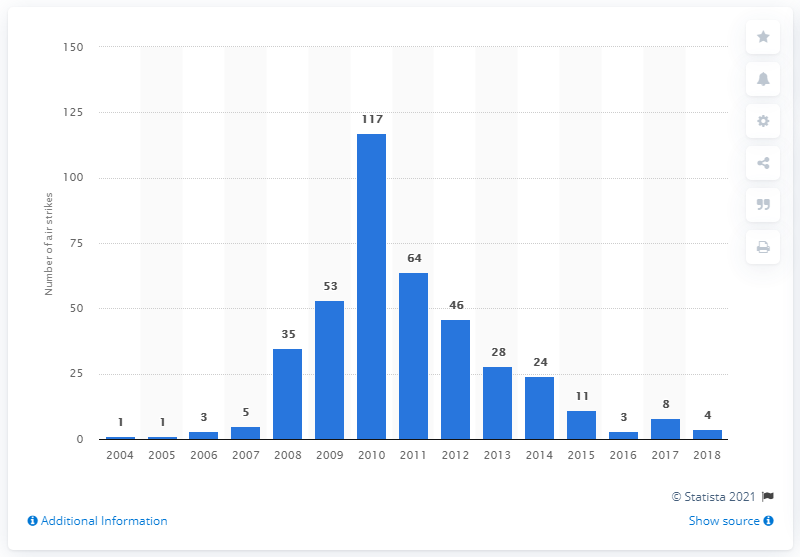List a handful of essential elements in this visual. There were 4 U.S. air strikes in Pakistan in 2018. 